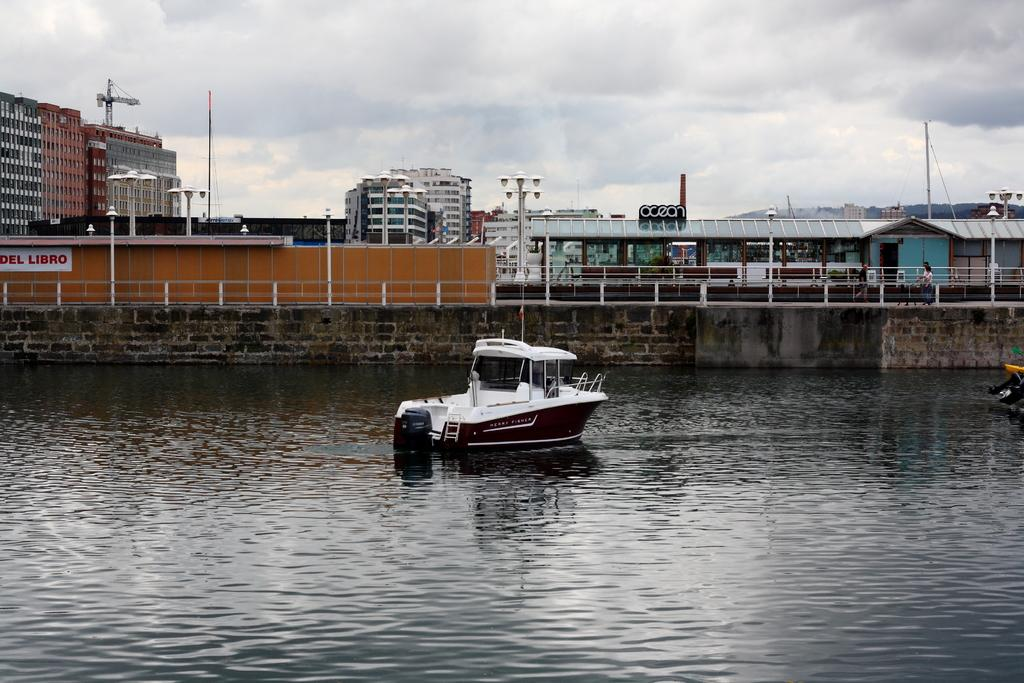Provide a one-sentence caption for the provided image. A boat on the water, behind it to the left is a sign that says Del Libro. 